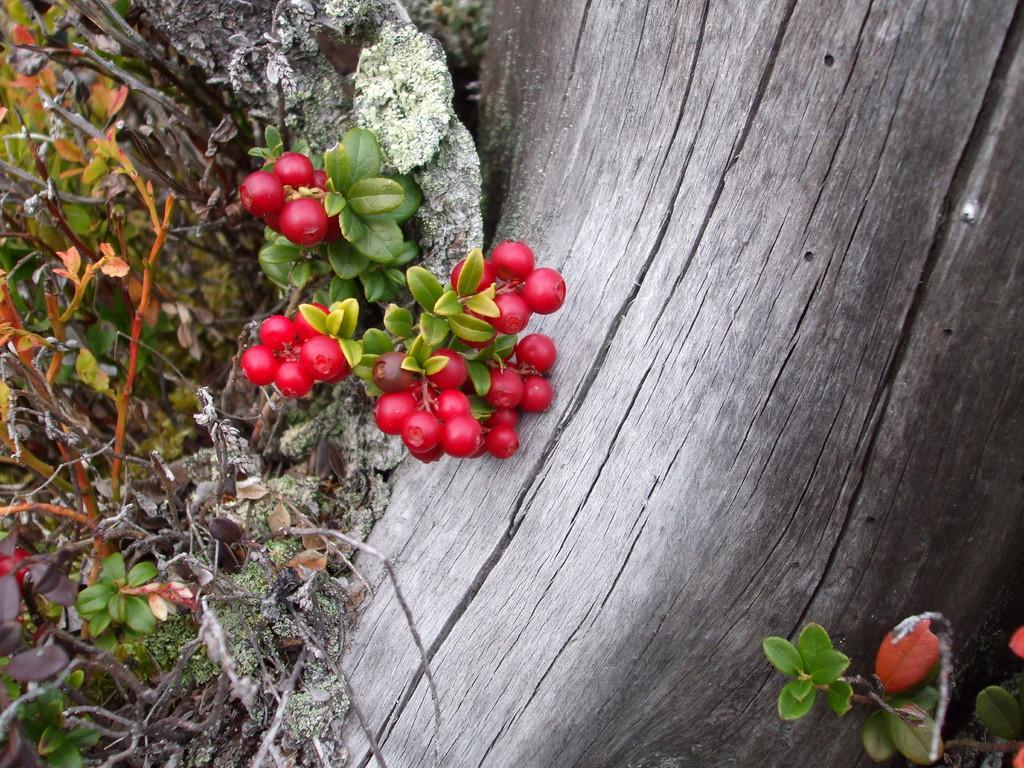In one or two sentences, can you explain what this image depicts? In this image I can see in the middle there are red color fruits of this tree. On the right side it looks like a bark of a tree. 